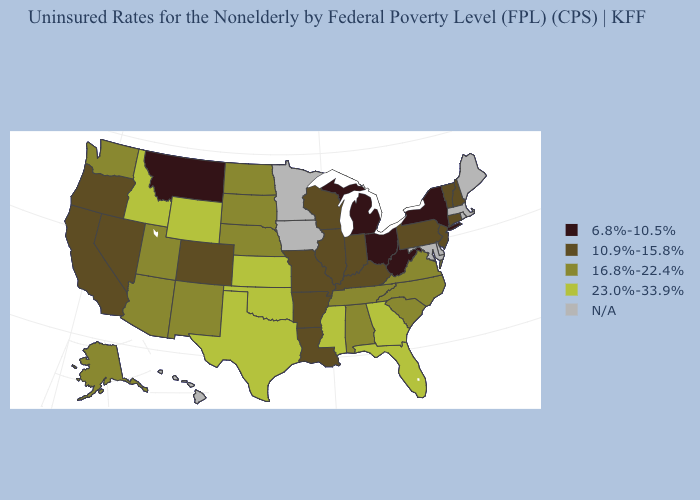What is the value of West Virginia?
Quick response, please. 6.8%-10.5%. Does Kansas have the highest value in the USA?
Short answer required. Yes. Does Connecticut have the highest value in the Northeast?
Answer briefly. Yes. Among the states that border North Dakota , which have the lowest value?
Concise answer only. Montana. Which states have the lowest value in the West?
Quick response, please. Montana. What is the value of Pennsylvania?
Short answer required. 10.9%-15.8%. Name the states that have a value in the range N/A?
Short answer required. Delaware, Hawaii, Iowa, Maine, Maryland, Massachusetts, Minnesota, Rhode Island. Name the states that have a value in the range 23.0%-33.9%?
Give a very brief answer. Florida, Georgia, Idaho, Kansas, Mississippi, Oklahoma, Texas, Wyoming. Which states have the lowest value in the USA?
Answer briefly. Michigan, Montana, New York, Ohio, West Virginia. Name the states that have a value in the range 6.8%-10.5%?
Keep it brief. Michigan, Montana, New York, Ohio, West Virginia. What is the value of Kentucky?
Answer briefly. 10.9%-15.8%. What is the value of Illinois?
Quick response, please. 10.9%-15.8%. Does the map have missing data?
Write a very short answer. Yes. Which states have the lowest value in the USA?
Be succinct. Michigan, Montana, New York, Ohio, West Virginia. Name the states that have a value in the range 23.0%-33.9%?
Be succinct. Florida, Georgia, Idaho, Kansas, Mississippi, Oklahoma, Texas, Wyoming. 